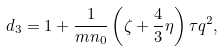Convert formula to latex. <formula><loc_0><loc_0><loc_500><loc_500>d _ { 3 } = 1 + \frac { 1 } { m n _ { 0 } } \left ( \zeta + \frac { 4 } { 3 } \eta \right ) \tau q ^ { 2 } ,</formula> 